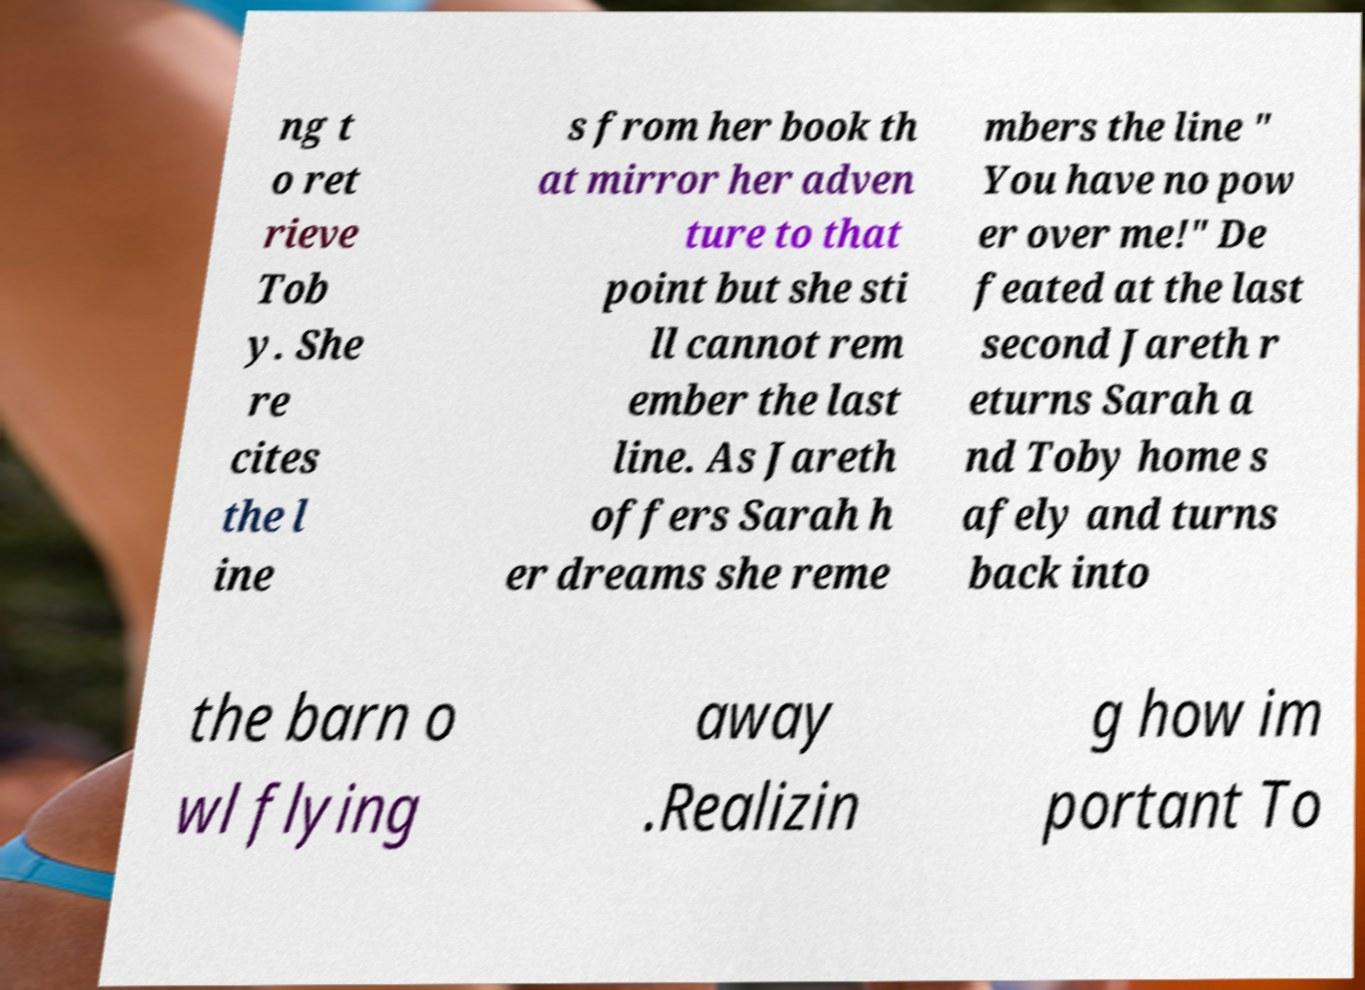There's text embedded in this image that I need extracted. Can you transcribe it verbatim? ng t o ret rieve Tob y. She re cites the l ine s from her book th at mirror her adven ture to that point but she sti ll cannot rem ember the last line. As Jareth offers Sarah h er dreams she reme mbers the line " You have no pow er over me!" De feated at the last second Jareth r eturns Sarah a nd Toby home s afely and turns back into the barn o wl flying away .Realizin g how im portant To 